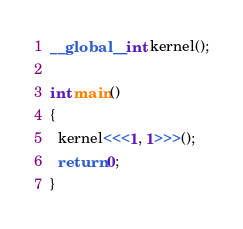Convert code to text. <code><loc_0><loc_0><loc_500><loc_500><_Cuda_>
__global__ int kernel();

int main()
{
  kernel<<<1, 1>>>();
  return 0;
}
</code> 